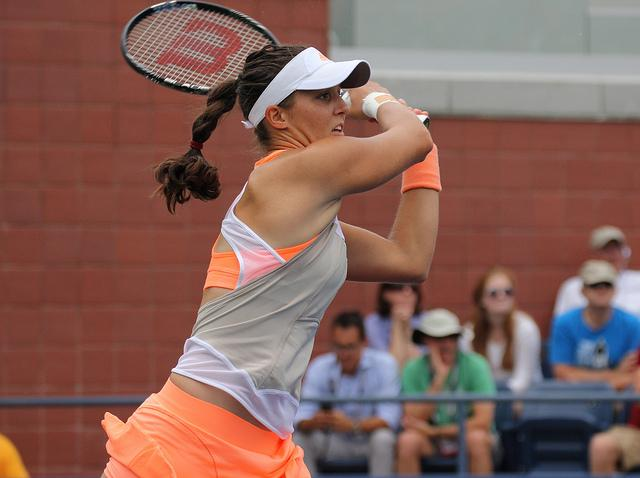What brand of tennis racket is she using to play?

Choices:
A) sportscraft
B) wilson
C) head
D) nike head 